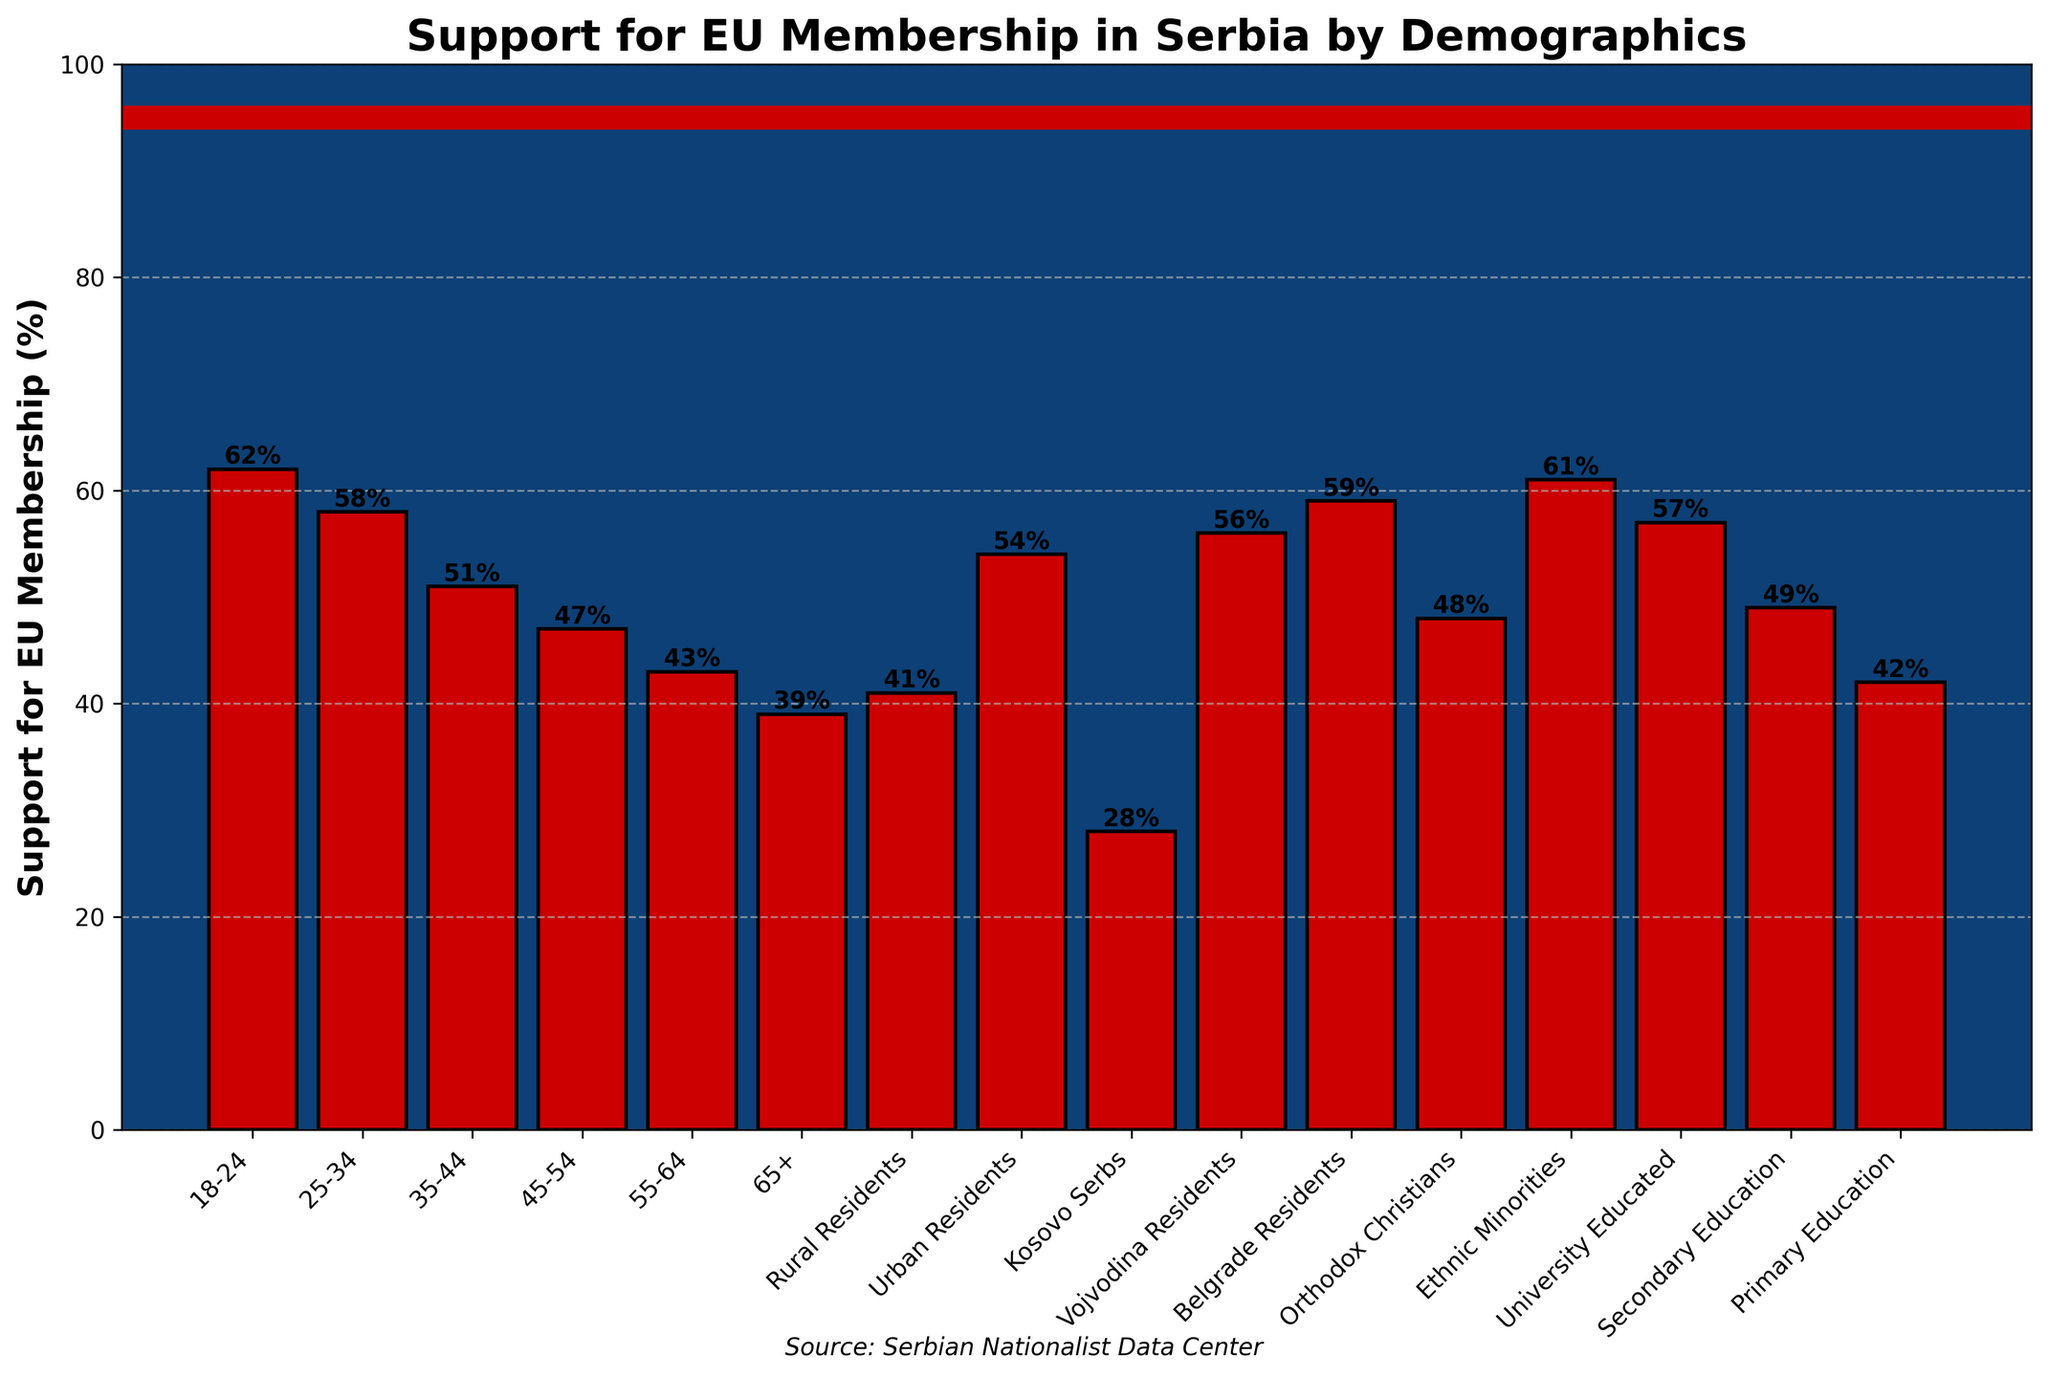Which age group shows the highest support for EU membership? The bar corresponding to the 18-24 age group reaches the highest point compared to others.
Answer: 18-24 Which group has the lowest support for EU membership? The bar representing Kosovo Serbs is significantly lower compared to all other groups.
Answer: Kosovo Serbs What is the difference in support for EU membership between the oldest and youngest age groups? The oldest age group (65+) has 39% support while the youngest (18-24) has 62%. The difference is 62% - 39% = 23%.
Answer: 23% Which has higher support for EU membership: Urban Residents or Rural Residents? The bar for Urban Residents is higher than that of Rural Residents.
Answer: Urban Residents What is the average support for EU membership among the 25-34, 35-44, and 45-54 age groups? (58% + 51% + 47%) / 3 = 156 / 3 = 52%
Answer: 52% Is the support for EU membership among Orthodox Christians higher or lower than that of University Educated individuals? The bar for Orthodox Christians is lower at 48%, whereas University Educated is higher at 57%.
Answer: Lower Compare the support for EU membership between Belgrade Residents and Vojvodina Residents. Which is higher? The bar for Belgrade Residents is slightly lower (59%) compared to Vojvodina Residents (56%).
Answer: Belgrade Residents Are Ethnic Minorities' support levels for EU membership closer to 18-24 age group or 65+ age group? Ethnic Minorities show 61% support which is closer to 18-24 age group (62%) than to the 65+ (39%).
Answer: Closer to 18-24 What is the median support value for EU membership across all groups provided? The median is the middle value when all percentages are listed in order. Ordering: 28, 39, 41, 42, 43, 47, 48, 49, 51, 54, 56, 57, 58, 59, 61, 62. The median values are 48 and 49, hence the median is (48+49)/2 = 48.5%
Answer: 48.5% What is the total combined percentage of support for EU membership among Secondary Education and Primary Education groups? Secondary Education has 49% support and Primary Education has 42%. Combined, it’s 49% + 42% = 91%.
Answer: 91% 